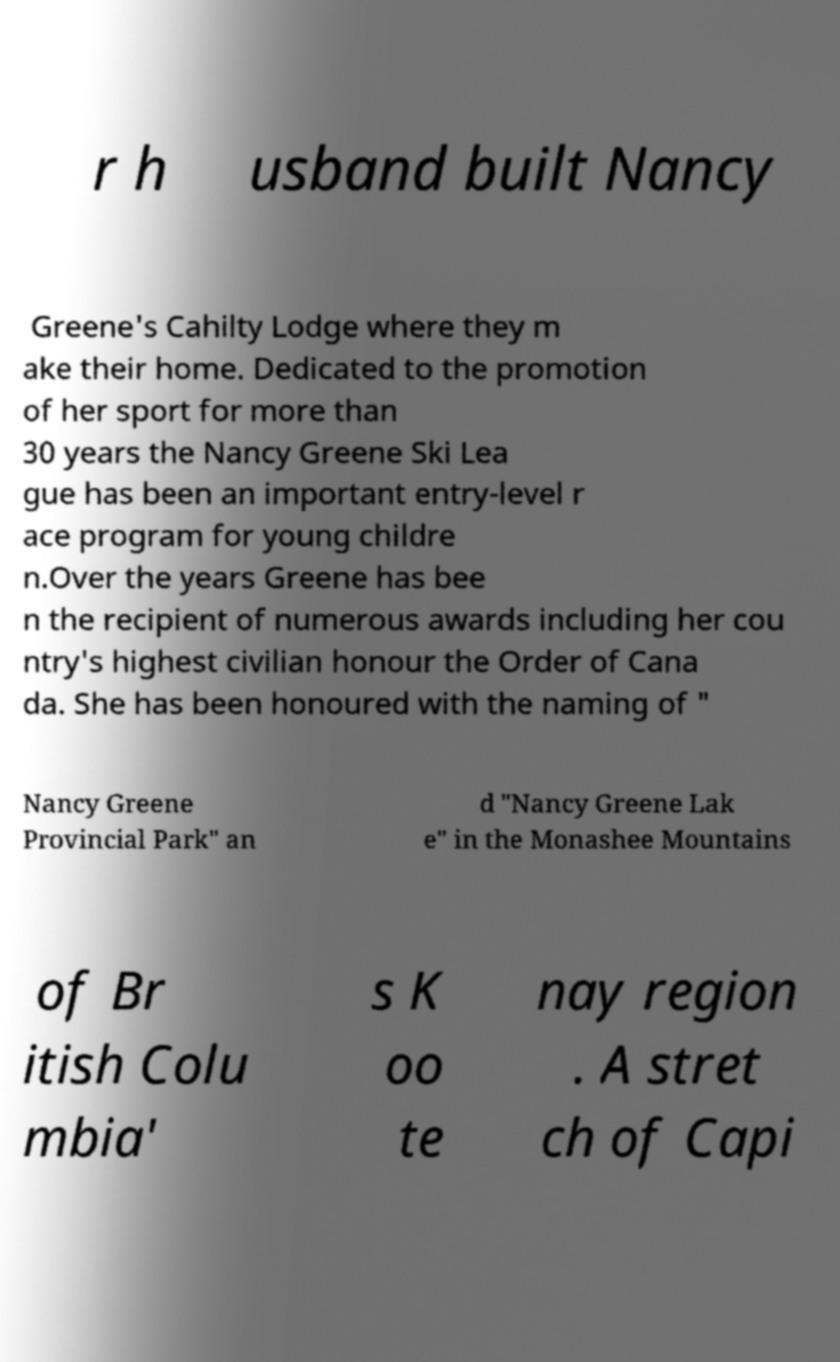Can you read and provide the text displayed in the image?This photo seems to have some interesting text. Can you extract and type it out for me? r h usband built Nancy Greene's Cahilty Lodge where they m ake their home. Dedicated to the promotion of her sport for more than 30 years the Nancy Greene Ski Lea gue has been an important entry-level r ace program for young childre n.Over the years Greene has bee n the recipient of numerous awards including her cou ntry's highest civilian honour the Order of Cana da. She has been honoured with the naming of " Nancy Greene Provincial Park" an d "Nancy Greene Lak e" in the Monashee Mountains of Br itish Colu mbia' s K oo te nay region . A stret ch of Capi 